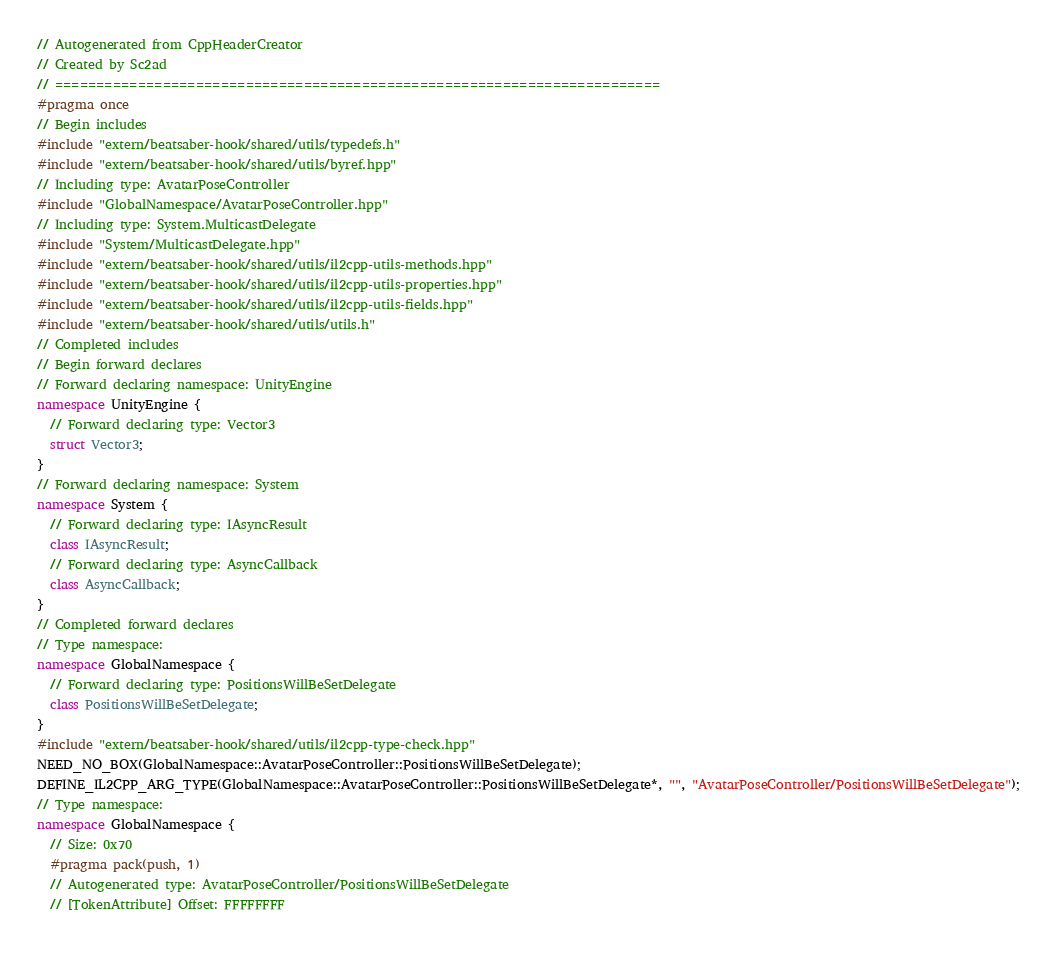Convert code to text. <code><loc_0><loc_0><loc_500><loc_500><_C++_>// Autogenerated from CppHeaderCreator
// Created by Sc2ad
// =========================================================================
#pragma once
// Begin includes
#include "extern/beatsaber-hook/shared/utils/typedefs.h"
#include "extern/beatsaber-hook/shared/utils/byref.hpp"
// Including type: AvatarPoseController
#include "GlobalNamespace/AvatarPoseController.hpp"
// Including type: System.MulticastDelegate
#include "System/MulticastDelegate.hpp"
#include "extern/beatsaber-hook/shared/utils/il2cpp-utils-methods.hpp"
#include "extern/beatsaber-hook/shared/utils/il2cpp-utils-properties.hpp"
#include "extern/beatsaber-hook/shared/utils/il2cpp-utils-fields.hpp"
#include "extern/beatsaber-hook/shared/utils/utils.h"
// Completed includes
// Begin forward declares
// Forward declaring namespace: UnityEngine
namespace UnityEngine {
  // Forward declaring type: Vector3
  struct Vector3;
}
// Forward declaring namespace: System
namespace System {
  // Forward declaring type: IAsyncResult
  class IAsyncResult;
  // Forward declaring type: AsyncCallback
  class AsyncCallback;
}
// Completed forward declares
// Type namespace: 
namespace GlobalNamespace {
  // Forward declaring type: PositionsWillBeSetDelegate
  class PositionsWillBeSetDelegate;
}
#include "extern/beatsaber-hook/shared/utils/il2cpp-type-check.hpp"
NEED_NO_BOX(GlobalNamespace::AvatarPoseController::PositionsWillBeSetDelegate);
DEFINE_IL2CPP_ARG_TYPE(GlobalNamespace::AvatarPoseController::PositionsWillBeSetDelegate*, "", "AvatarPoseController/PositionsWillBeSetDelegate");
// Type namespace: 
namespace GlobalNamespace {
  // Size: 0x70
  #pragma pack(push, 1)
  // Autogenerated type: AvatarPoseController/PositionsWillBeSetDelegate
  // [TokenAttribute] Offset: FFFFFFFF</code> 